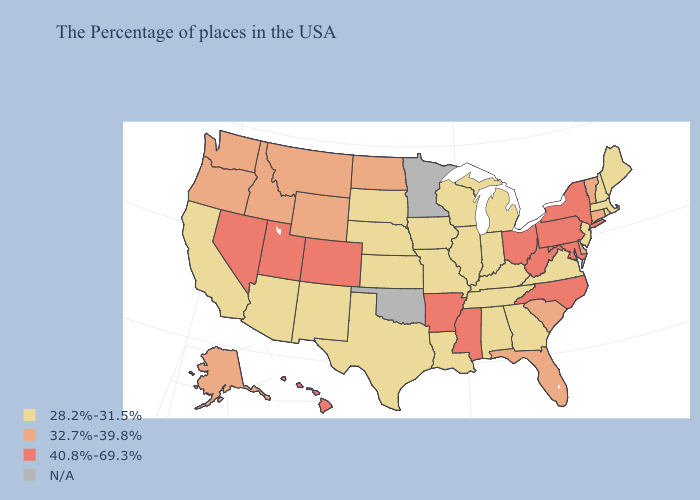What is the highest value in states that border Montana?
Short answer required. 32.7%-39.8%. What is the value of South Dakota?
Short answer required. 28.2%-31.5%. Name the states that have a value in the range 40.8%-69.3%?
Answer briefly. New York, Maryland, Pennsylvania, North Carolina, West Virginia, Ohio, Mississippi, Arkansas, Colorado, Utah, Nevada, Hawaii. Does Utah have the lowest value in the West?
Be succinct. No. What is the value of Missouri?
Concise answer only. 28.2%-31.5%. Name the states that have a value in the range 32.7%-39.8%?
Quick response, please. Vermont, Connecticut, Delaware, South Carolina, Florida, North Dakota, Wyoming, Montana, Idaho, Washington, Oregon, Alaska. Name the states that have a value in the range 40.8%-69.3%?
Keep it brief. New York, Maryland, Pennsylvania, North Carolina, West Virginia, Ohio, Mississippi, Arkansas, Colorado, Utah, Nevada, Hawaii. Does Louisiana have the lowest value in the USA?
Keep it brief. Yes. What is the value of Arkansas?
Short answer required. 40.8%-69.3%. Does the first symbol in the legend represent the smallest category?
Answer briefly. Yes. What is the value of Vermont?
Answer briefly. 32.7%-39.8%. Does Nevada have the highest value in the USA?
Answer briefly. Yes. What is the value of North Carolina?
Write a very short answer. 40.8%-69.3%. Among the states that border South Carolina , does Georgia have the lowest value?
Short answer required. Yes. Which states hav the highest value in the MidWest?
Quick response, please. Ohio. 